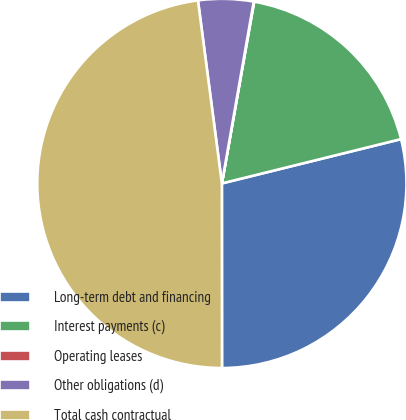Convert chart. <chart><loc_0><loc_0><loc_500><loc_500><pie_chart><fcel>Long-term debt and financing<fcel>Interest payments (c)<fcel>Operating leases<fcel>Other obligations (d)<fcel>Total cash contractual<nl><fcel>28.85%<fcel>18.34%<fcel>0.04%<fcel>4.83%<fcel>47.94%<nl></chart> 